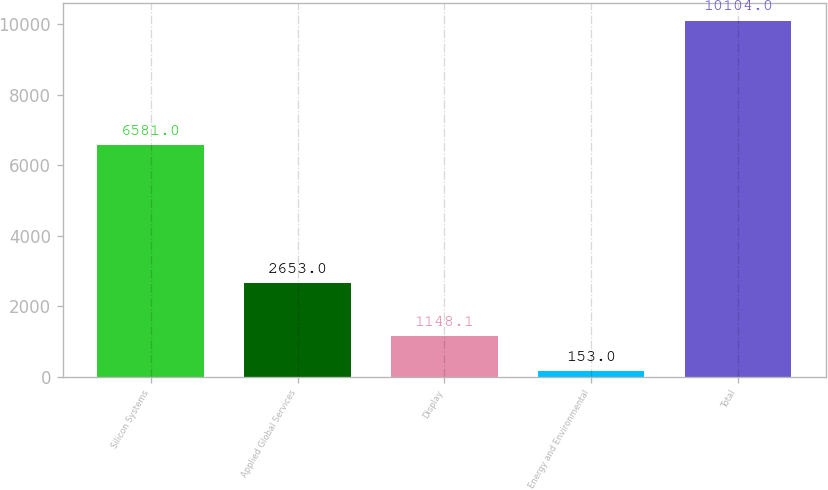Convert chart to OTSL. <chart><loc_0><loc_0><loc_500><loc_500><bar_chart><fcel>Silicon Systems<fcel>Applied Global Services<fcel>Display<fcel>Energy and Environmental<fcel>Total<nl><fcel>6581<fcel>2653<fcel>1148.1<fcel>153<fcel>10104<nl></chart> 